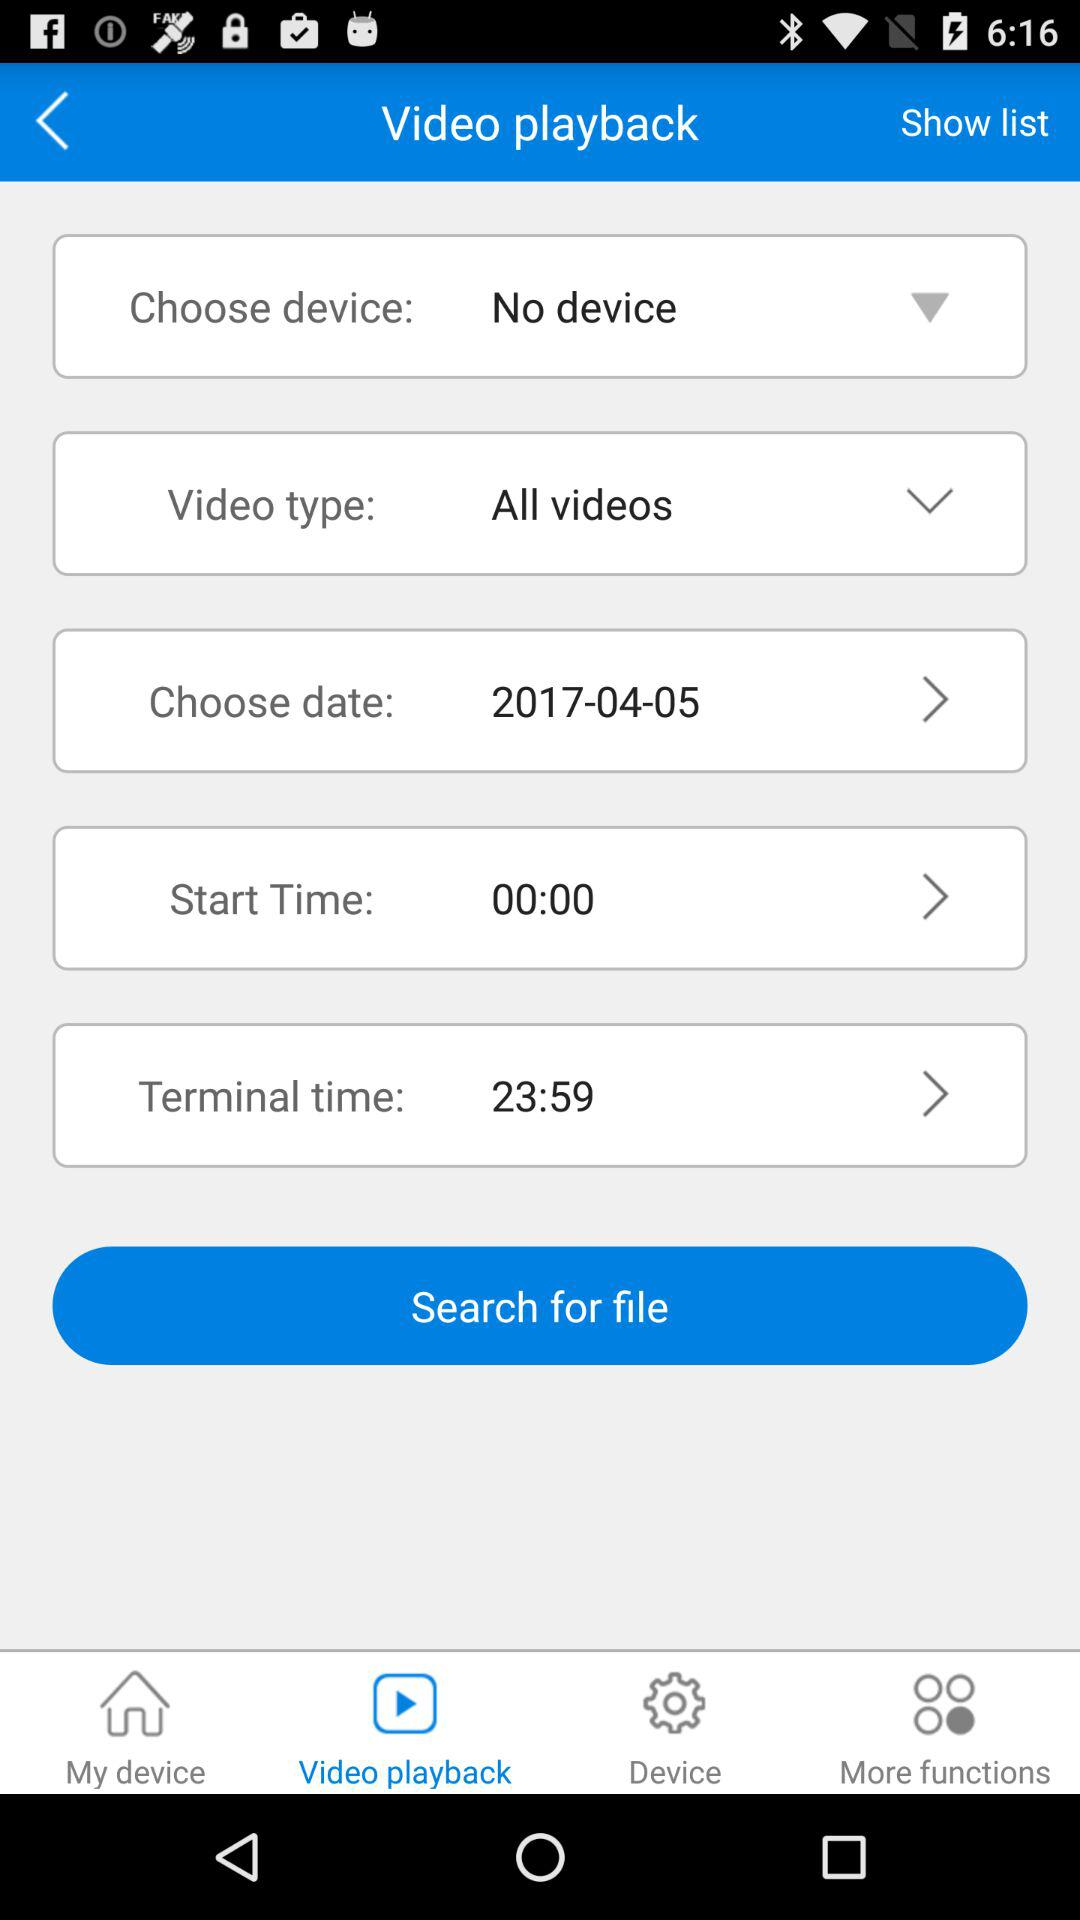Which device is selected? The selected device is "No device". 